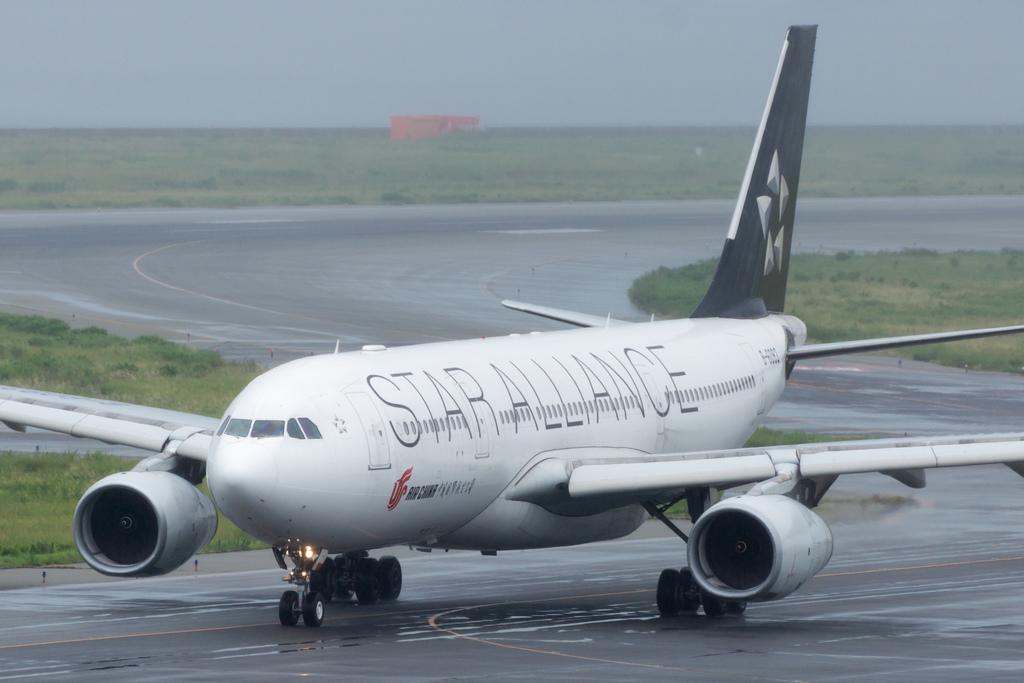<image>
Relay a brief, clear account of the picture shown. White and gray Star Alliance airplane from Air China 